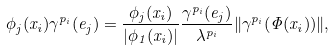<formula> <loc_0><loc_0><loc_500><loc_500>\phi _ { j } ( x _ { i } ) \gamma ^ { p _ { i } } ( e _ { j } ) = \frac { \phi _ { j } ( x _ { i } ) } { | \phi _ { 1 } ( x _ { i } ) | } \frac { \gamma ^ { p _ { i } } ( e _ { j } ) } { \lambda ^ { p _ { i } } } \| \gamma ^ { p _ { i } } ( \Phi ( x _ { i } ) ) \| ,</formula> 